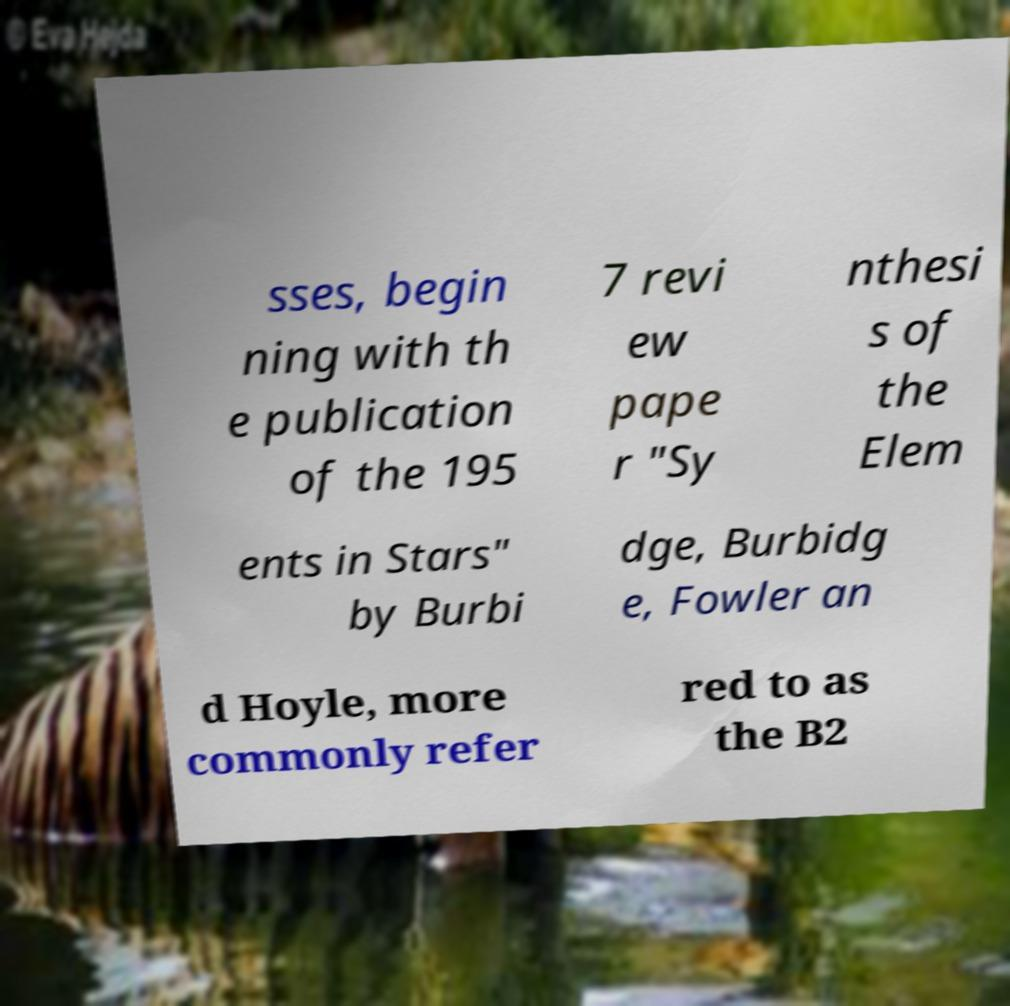Can you accurately transcribe the text from the provided image for me? sses, begin ning with th e publication of the 195 7 revi ew pape r "Sy nthesi s of the Elem ents in Stars" by Burbi dge, Burbidg e, Fowler an d Hoyle, more commonly refer red to as the B2 